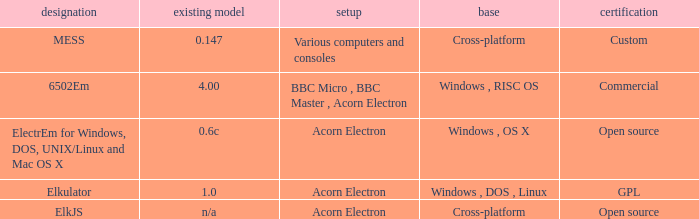What is the system called that is named ELKJS? Acorn Electron. 